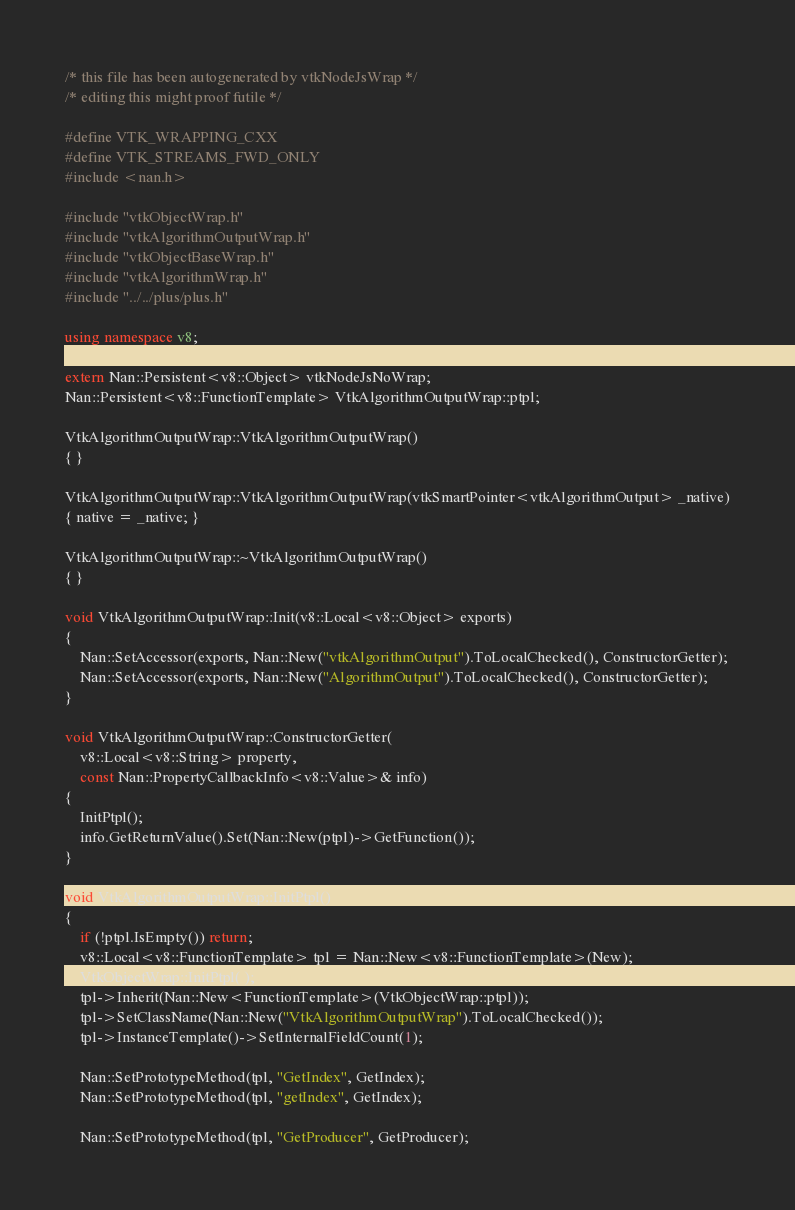<code> <loc_0><loc_0><loc_500><loc_500><_C++_>/* this file has been autogenerated by vtkNodeJsWrap */
/* editing this might proof futile */

#define VTK_WRAPPING_CXX
#define VTK_STREAMS_FWD_ONLY
#include <nan.h>

#include "vtkObjectWrap.h"
#include "vtkAlgorithmOutputWrap.h"
#include "vtkObjectBaseWrap.h"
#include "vtkAlgorithmWrap.h"
#include "../../plus/plus.h"

using namespace v8;

extern Nan::Persistent<v8::Object> vtkNodeJsNoWrap;
Nan::Persistent<v8::FunctionTemplate> VtkAlgorithmOutputWrap::ptpl;

VtkAlgorithmOutputWrap::VtkAlgorithmOutputWrap()
{ }

VtkAlgorithmOutputWrap::VtkAlgorithmOutputWrap(vtkSmartPointer<vtkAlgorithmOutput> _native)
{ native = _native; }

VtkAlgorithmOutputWrap::~VtkAlgorithmOutputWrap()
{ }

void VtkAlgorithmOutputWrap::Init(v8::Local<v8::Object> exports)
{
	Nan::SetAccessor(exports, Nan::New("vtkAlgorithmOutput").ToLocalChecked(), ConstructorGetter);
	Nan::SetAccessor(exports, Nan::New("AlgorithmOutput").ToLocalChecked(), ConstructorGetter);
}

void VtkAlgorithmOutputWrap::ConstructorGetter(
	v8::Local<v8::String> property,
	const Nan::PropertyCallbackInfo<v8::Value>& info)
{
	InitPtpl();
	info.GetReturnValue().Set(Nan::New(ptpl)->GetFunction());
}

void VtkAlgorithmOutputWrap::InitPtpl()
{
	if (!ptpl.IsEmpty()) return;
	v8::Local<v8::FunctionTemplate> tpl = Nan::New<v8::FunctionTemplate>(New);
	VtkObjectWrap::InitPtpl( );
	tpl->Inherit(Nan::New<FunctionTemplate>(VtkObjectWrap::ptpl));
	tpl->SetClassName(Nan::New("VtkAlgorithmOutputWrap").ToLocalChecked());
	tpl->InstanceTemplate()->SetInternalFieldCount(1);

	Nan::SetPrototypeMethod(tpl, "GetIndex", GetIndex);
	Nan::SetPrototypeMethod(tpl, "getIndex", GetIndex);

	Nan::SetPrototypeMethod(tpl, "GetProducer", GetProducer);</code> 